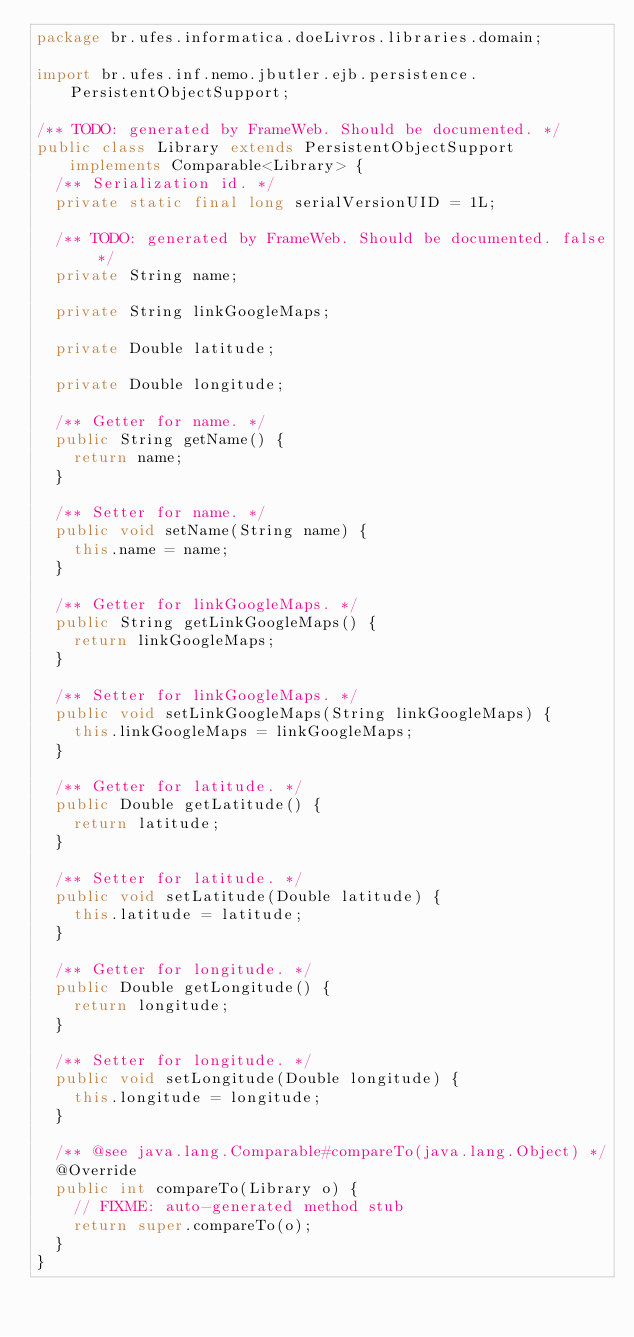<code> <loc_0><loc_0><loc_500><loc_500><_Java_>package br.ufes.informatica.doeLivros.libraries.domain;

import br.ufes.inf.nemo.jbutler.ejb.persistence.PersistentObjectSupport;

/** TODO: generated by FrameWeb. Should be documented. */
public class Library extends PersistentObjectSupport implements Comparable<Library> {
	/** Serialization id. */
	private static final long serialVersionUID = 1L;

	/** TODO: generated by FrameWeb. Should be documented. false */
	private String name;
	
	private String linkGoogleMaps;
	
	private Double latitude;

	private Double longitude;
	
	/** Getter for name. */
	public String getName() {
		return name;
	}

	/** Setter for name. */
	public void setName(String name) {
		this.name = name;
	}
	
	/** Getter for linkGoogleMaps. */
	public String getLinkGoogleMaps() {
		return linkGoogleMaps;
	}

	/** Setter for linkGoogleMaps. */
	public void setLinkGoogleMaps(String linkGoogleMaps) {
		this.linkGoogleMaps = linkGoogleMaps;
	}
	
	/** Getter for latitude. */
	public Double getLatitude() {
		return latitude;
	}

	/** Setter for latitude. */
	public void setLatitude(Double latitude) {
		this.latitude = latitude;
	}
	
	/** Getter for longitude. */
	public Double getLongitude() {
		return longitude;
	}

	/** Setter for longitude. */
	public void setLongitude(Double longitude) {
		this.longitude = longitude;
	}

	/** @see java.lang.Comparable#compareTo(java.lang.Object) */
	@Override
	public int compareTo(Library o) {
		// FIXME: auto-generated method stub
		return super.compareTo(o);
	}
}</code> 